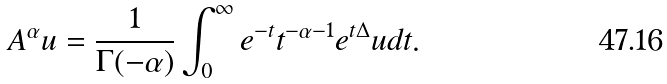Convert formula to latex. <formula><loc_0><loc_0><loc_500><loc_500>A ^ { \alpha } u = \frac { 1 } { \Gamma ( - \alpha ) } \int _ { 0 } ^ { \infty } e ^ { - t } t ^ { - \alpha - 1 } e ^ { t \Delta } u d t .</formula> 